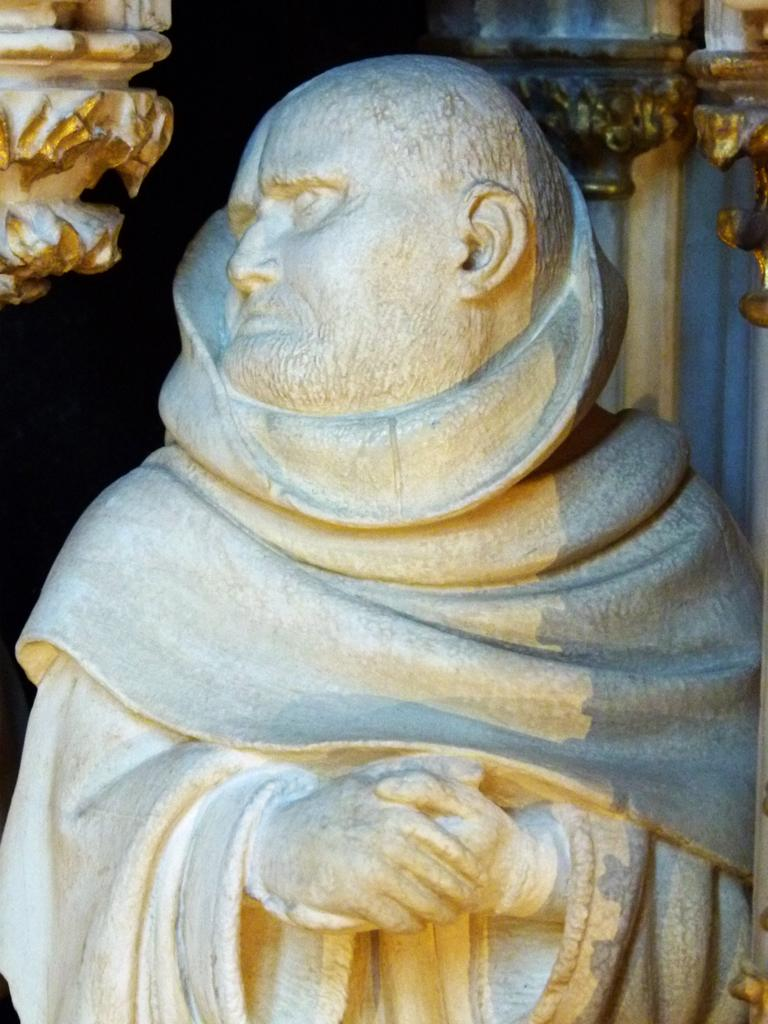What is the main subject of the image? There is a statue of a man in the image. How is the statue being treated in the image? The statue is wrapped by a cloth. What can be seen in the background of the image? There are pillars in the background of the image. What is the color of the pillars? The pillars are in golden color. How much income does the kitty earn from the statue in the image? There is no kitty present in the image, and therefore no income can be associated with it. 